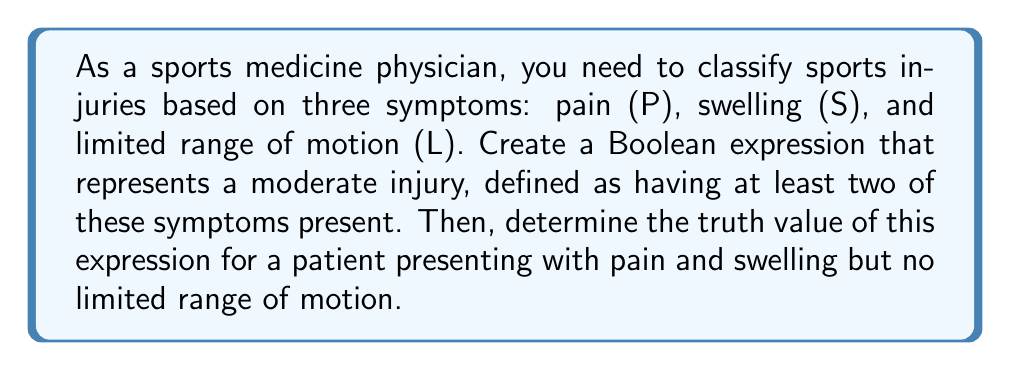Help me with this question. 1. First, let's define our Boolean variables:
   P: Pain (1 if present, 0 if absent)
   S: Swelling (1 if present, 0 if absent)
   L: Limited range of motion (1 if present, 0 if absent)

2. A moderate injury is defined as having at least two of these symptoms. We can represent this using Boolean algebra as:

   $$(P \land S) \lor (P \land L) \lor (S \land L)$$

   This expression is true if at least two of the symptoms are present.

3. For the given patient:
   P = 1 (pain is present)
   S = 1 (swelling is present)
   L = 0 (no limited range of motion)

4. Let's evaluate the expression:

   $$(P \land S) \lor (P \land L) \lor (S \land L)$$
   $$= (1 \land 1) \lor (1 \land 0) \lor (1 \land 0)$$
   $$= 1 \lor 0 \lor 0$$
   $$= 1$$

5. The result is 1 (true), which means the patient's condition meets the criteria for a moderate injury according to our classification.
Answer: 1 